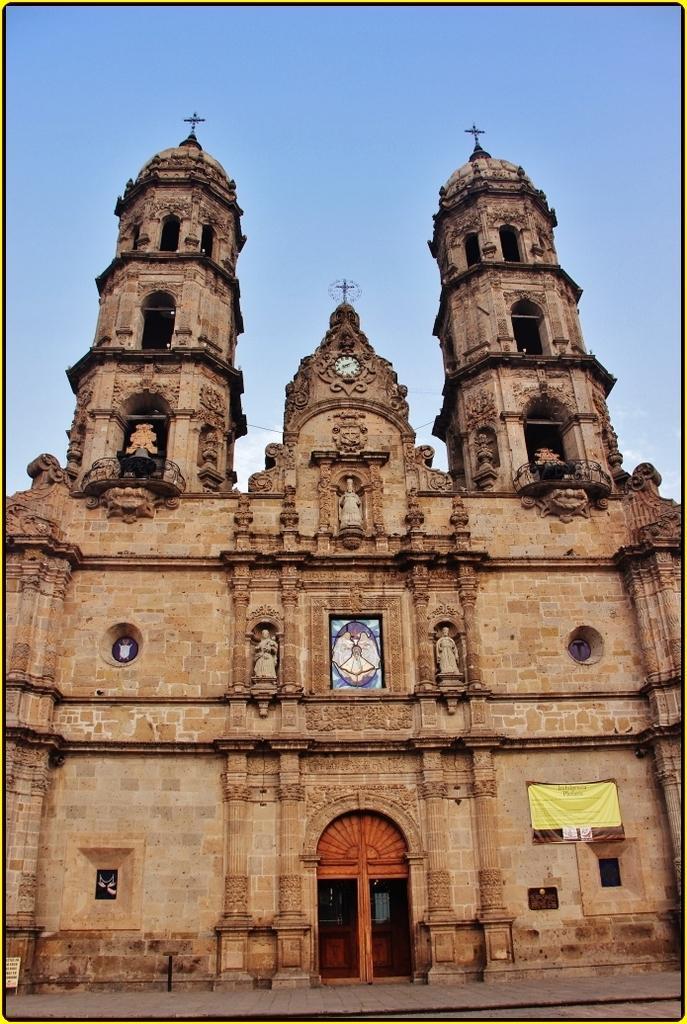Please provide a concise description of this image. In this image we can see an ancient architecture, banner, statues, and a clock. In the background there is sky. 